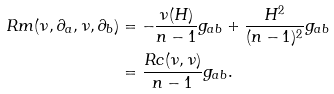Convert formula to latex. <formula><loc_0><loc_0><loc_500><loc_500>R m ( \nu , \partial _ { a } , \nu , \partial _ { b } ) & = - \frac { \nu ( H ) } { n - 1 } g _ { a b } + \frac { H ^ { 2 } } { ( n - 1 ) ^ { 2 } } g _ { a b } \\ & = \frac { R c ( \nu , \nu ) } { n - 1 } g _ { a b } . \\</formula> 